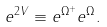<formula> <loc_0><loc_0><loc_500><loc_500>e ^ { 2 V } \equiv e ^ { \Omega ^ { + } } e ^ { \Omega } .</formula> 